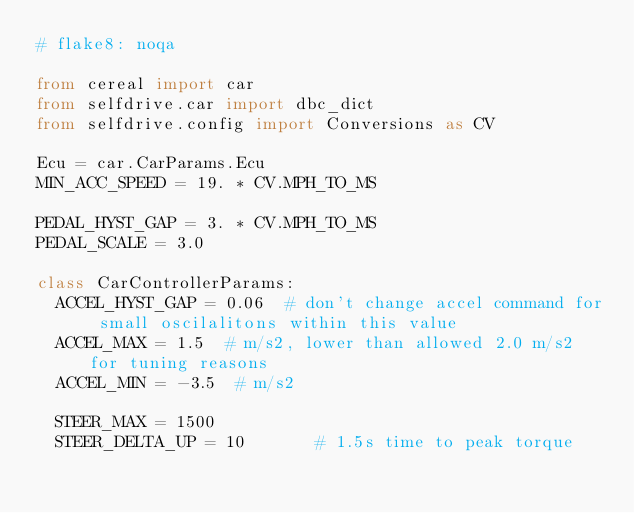<code> <loc_0><loc_0><loc_500><loc_500><_Python_># flake8: noqa

from cereal import car
from selfdrive.car import dbc_dict
from selfdrive.config import Conversions as CV

Ecu = car.CarParams.Ecu
MIN_ACC_SPEED = 19. * CV.MPH_TO_MS

PEDAL_HYST_GAP = 3. * CV.MPH_TO_MS
PEDAL_SCALE = 3.0

class CarControllerParams:
  ACCEL_HYST_GAP = 0.06  # don't change accel command for small oscilalitons within this value
  ACCEL_MAX = 1.5  # m/s2, lower than allowed 2.0 m/s2 for tuning reasons
  ACCEL_MIN = -3.5  # m/s2

  STEER_MAX = 1500
  STEER_DELTA_UP = 10       # 1.5s time to peak torque</code> 